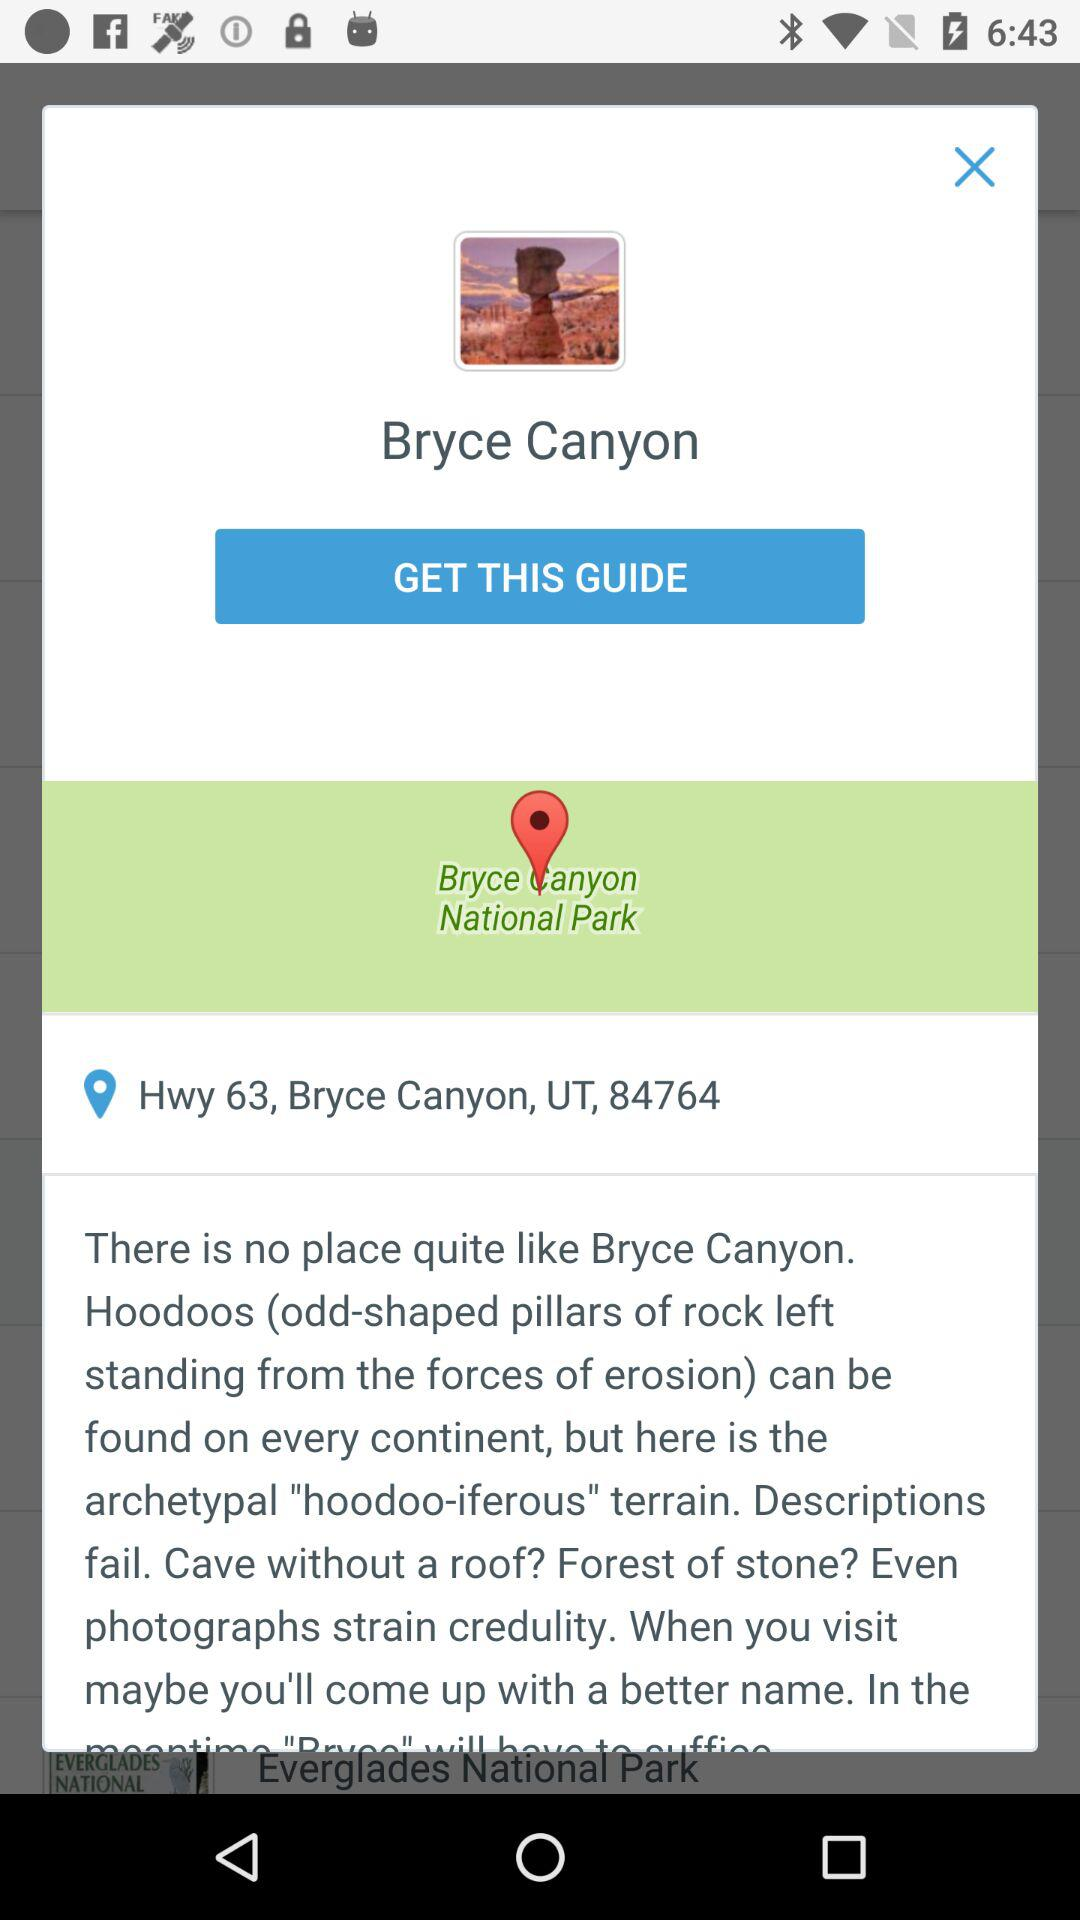What is the location? The location is "Hwy 63, Bryce Canyon, UT, 84764". 